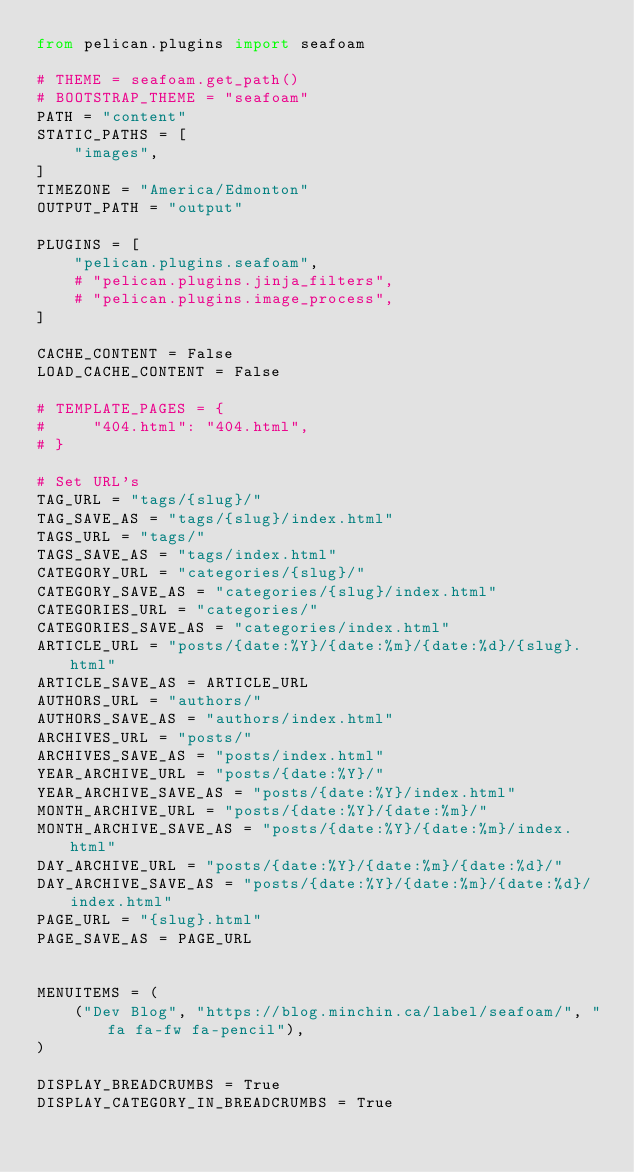Convert code to text. <code><loc_0><loc_0><loc_500><loc_500><_Python_>from pelican.plugins import seafoam

# THEME = seafoam.get_path()
# BOOTSTRAP_THEME = "seafoam"
PATH = "content"
STATIC_PATHS = [
    "images",
]
TIMEZONE = "America/Edmonton"
OUTPUT_PATH = "output"

PLUGINS = [
    "pelican.plugins.seafoam",
    # "pelican.plugins.jinja_filters",
    # "pelican.plugins.image_process",
]

CACHE_CONTENT = False
LOAD_CACHE_CONTENT = False

# TEMPLATE_PAGES = {
#     "404.html": "404.html",
# }

# Set URL's
TAG_URL = "tags/{slug}/"
TAG_SAVE_AS = "tags/{slug}/index.html"
TAGS_URL = "tags/"
TAGS_SAVE_AS = "tags/index.html"
CATEGORY_URL = "categories/{slug}/"
CATEGORY_SAVE_AS = "categories/{slug}/index.html"
CATEGORIES_URL = "categories/"
CATEGORIES_SAVE_AS = "categories/index.html"
ARTICLE_URL = "posts/{date:%Y}/{date:%m}/{date:%d}/{slug}.html"
ARTICLE_SAVE_AS = ARTICLE_URL
AUTHORS_URL = "authors/"
AUTHORS_SAVE_AS = "authors/index.html"
ARCHIVES_URL = "posts/"
ARCHIVES_SAVE_AS = "posts/index.html"
YEAR_ARCHIVE_URL = "posts/{date:%Y}/"
YEAR_ARCHIVE_SAVE_AS = "posts/{date:%Y}/index.html"
MONTH_ARCHIVE_URL = "posts/{date:%Y}/{date:%m}/"
MONTH_ARCHIVE_SAVE_AS = "posts/{date:%Y}/{date:%m}/index.html"
DAY_ARCHIVE_URL = "posts/{date:%Y}/{date:%m}/{date:%d}/"
DAY_ARCHIVE_SAVE_AS = "posts/{date:%Y}/{date:%m}/{date:%d}/index.html"
PAGE_URL = "{slug}.html"
PAGE_SAVE_AS = PAGE_URL


MENUITEMS = (
    ("Dev Blog", "https://blog.minchin.ca/label/seafoam/", "fa fa-fw fa-pencil"),
)

DISPLAY_BREADCRUMBS = True
DISPLAY_CATEGORY_IN_BREADCRUMBS = True
</code> 